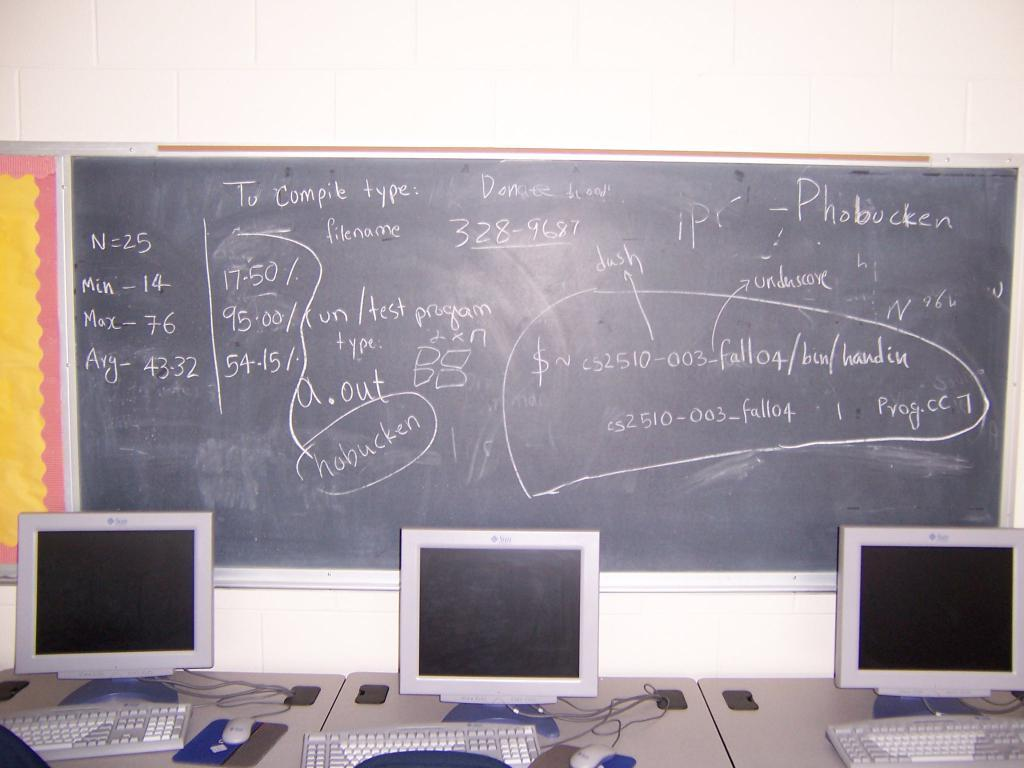<image>
Provide a brief description of the given image. Three computer monitors are in front of a chalkboard with the word Phobucken among other things. 